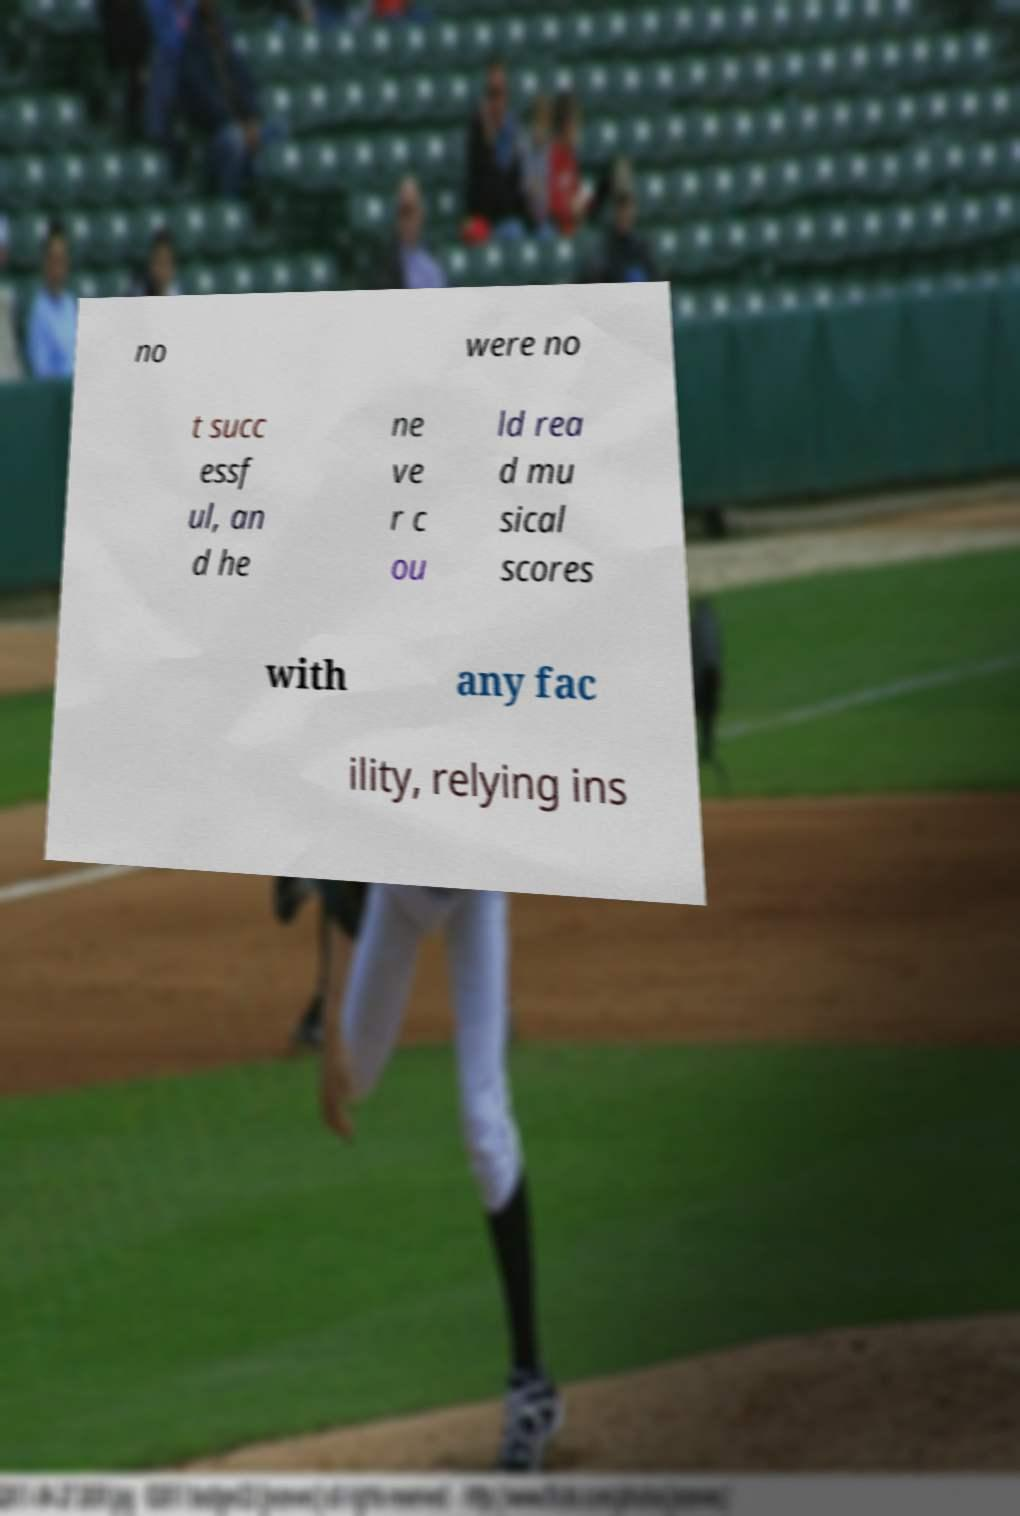Please read and relay the text visible in this image. What does it say? no were no t succ essf ul, an d he ne ve r c ou ld rea d mu sical scores with any fac ility, relying ins 